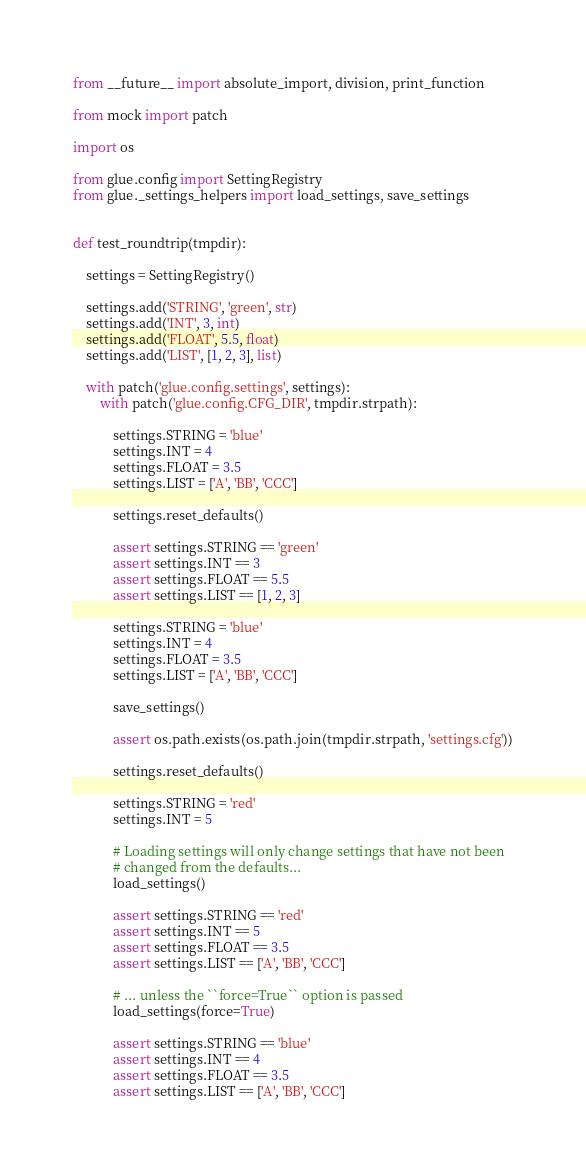<code> <loc_0><loc_0><loc_500><loc_500><_Python_>from __future__ import absolute_import, division, print_function

from mock import patch

import os

from glue.config import SettingRegistry
from glue._settings_helpers import load_settings, save_settings


def test_roundtrip(tmpdir):

    settings = SettingRegistry()

    settings.add('STRING', 'green', str)
    settings.add('INT', 3, int)
    settings.add('FLOAT', 5.5, float)
    settings.add('LIST', [1, 2, 3], list)

    with patch('glue.config.settings', settings):
        with patch('glue.config.CFG_DIR', tmpdir.strpath):

            settings.STRING = 'blue'
            settings.INT = 4
            settings.FLOAT = 3.5
            settings.LIST = ['A', 'BB', 'CCC']

            settings.reset_defaults()

            assert settings.STRING == 'green'
            assert settings.INT == 3
            assert settings.FLOAT == 5.5
            assert settings.LIST == [1, 2, 3]

            settings.STRING = 'blue'
            settings.INT = 4
            settings.FLOAT = 3.5
            settings.LIST = ['A', 'BB', 'CCC']

            save_settings()

            assert os.path.exists(os.path.join(tmpdir.strpath, 'settings.cfg'))

            settings.reset_defaults()

            settings.STRING = 'red'
            settings.INT = 5

            # Loading settings will only change settings that have not been
            # changed from the defaults...
            load_settings()

            assert settings.STRING == 'red'
            assert settings.INT == 5
            assert settings.FLOAT == 3.5
            assert settings.LIST == ['A', 'BB', 'CCC']

            # ... unless the ``force=True`` option is passed
            load_settings(force=True)

            assert settings.STRING == 'blue'
            assert settings.INT == 4
            assert settings.FLOAT == 3.5
            assert settings.LIST == ['A', 'BB', 'CCC']
</code> 